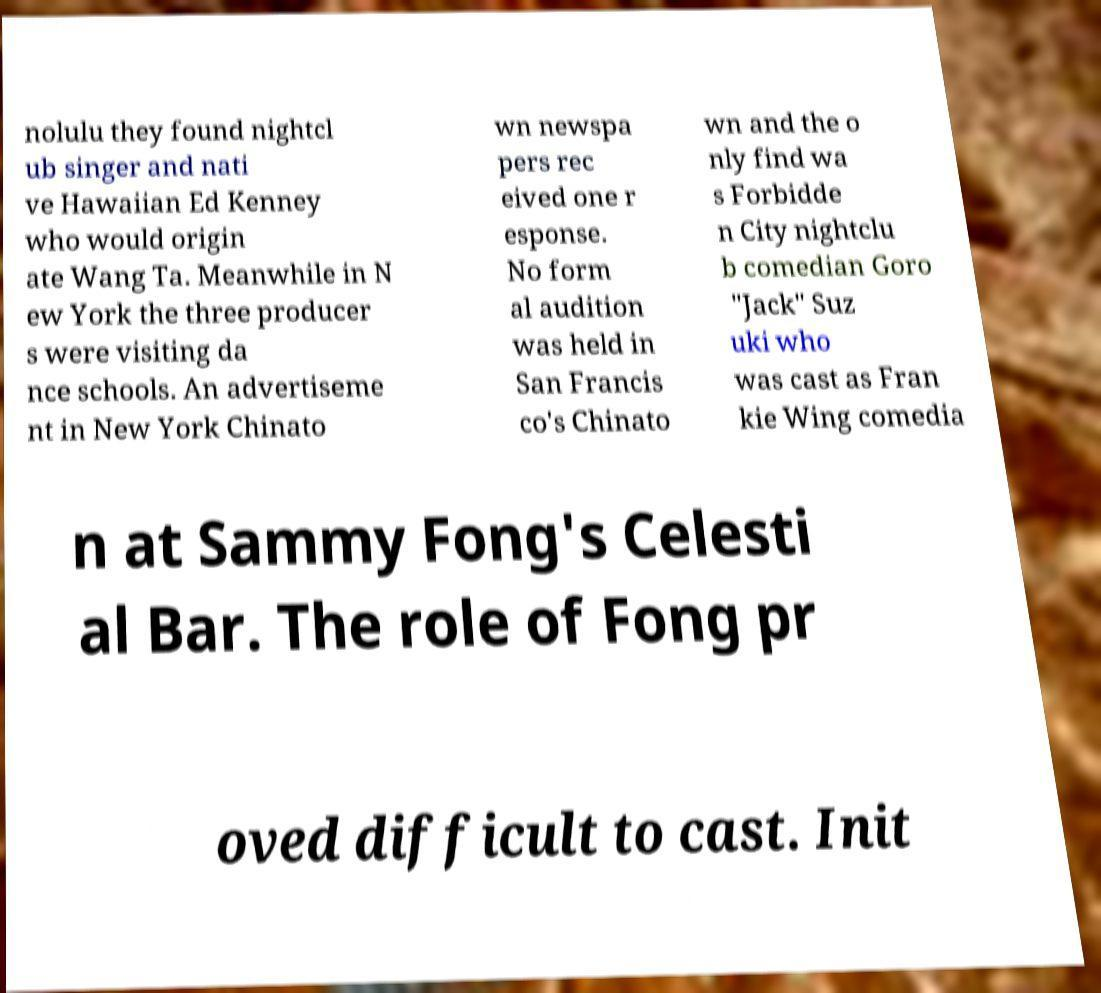Could you assist in decoding the text presented in this image and type it out clearly? nolulu they found nightcl ub singer and nati ve Hawaiian Ed Kenney who would origin ate Wang Ta. Meanwhile in N ew York the three producer s were visiting da nce schools. An advertiseme nt in New York Chinato wn newspa pers rec eived one r esponse. No form al audition was held in San Francis co's Chinato wn and the o nly find wa s Forbidde n City nightclu b comedian Goro "Jack" Suz uki who was cast as Fran kie Wing comedia n at Sammy Fong's Celesti al Bar. The role of Fong pr oved difficult to cast. Init 